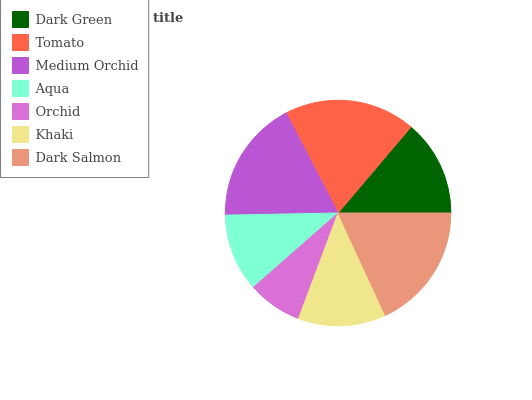Is Orchid the minimum?
Answer yes or no. Yes. Is Tomato the maximum?
Answer yes or no. Yes. Is Medium Orchid the minimum?
Answer yes or no. No. Is Medium Orchid the maximum?
Answer yes or no. No. Is Tomato greater than Medium Orchid?
Answer yes or no. Yes. Is Medium Orchid less than Tomato?
Answer yes or no. Yes. Is Medium Orchid greater than Tomato?
Answer yes or no. No. Is Tomato less than Medium Orchid?
Answer yes or no. No. Is Dark Green the high median?
Answer yes or no. Yes. Is Dark Green the low median?
Answer yes or no. Yes. Is Khaki the high median?
Answer yes or no. No. Is Aqua the low median?
Answer yes or no. No. 